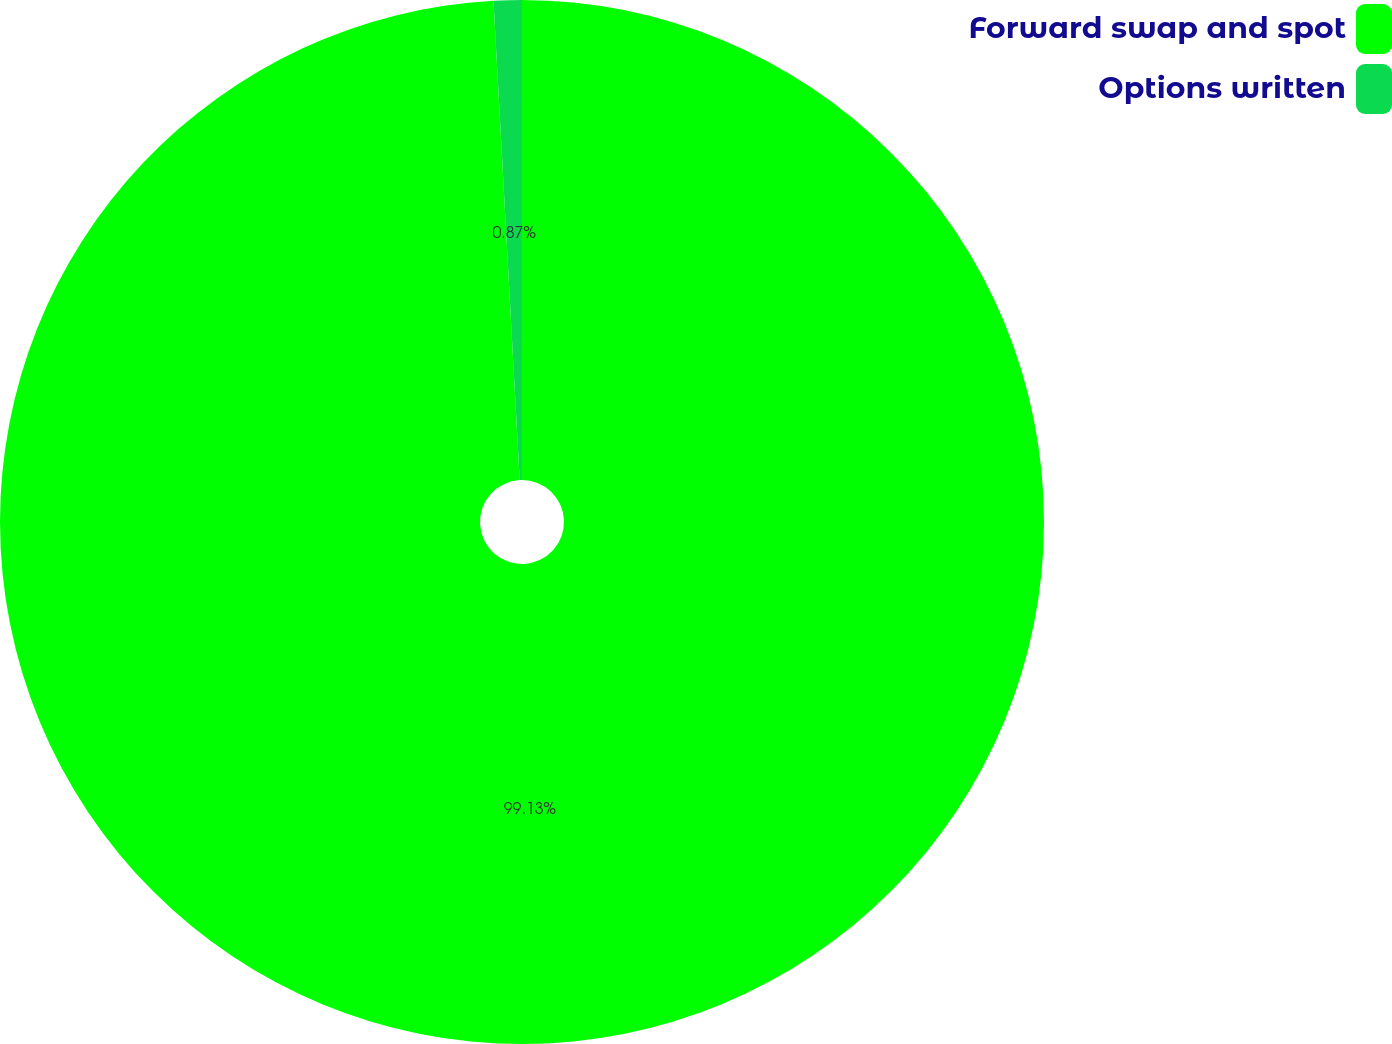Convert chart to OTSL. <chart><loc_0><loc_0><loc_500><loc_500><pie_chart><fcel>Forward swap and spot<fcel>Options written<nl><fcel>99.13%<fcel>0.87%<nl></chart> 